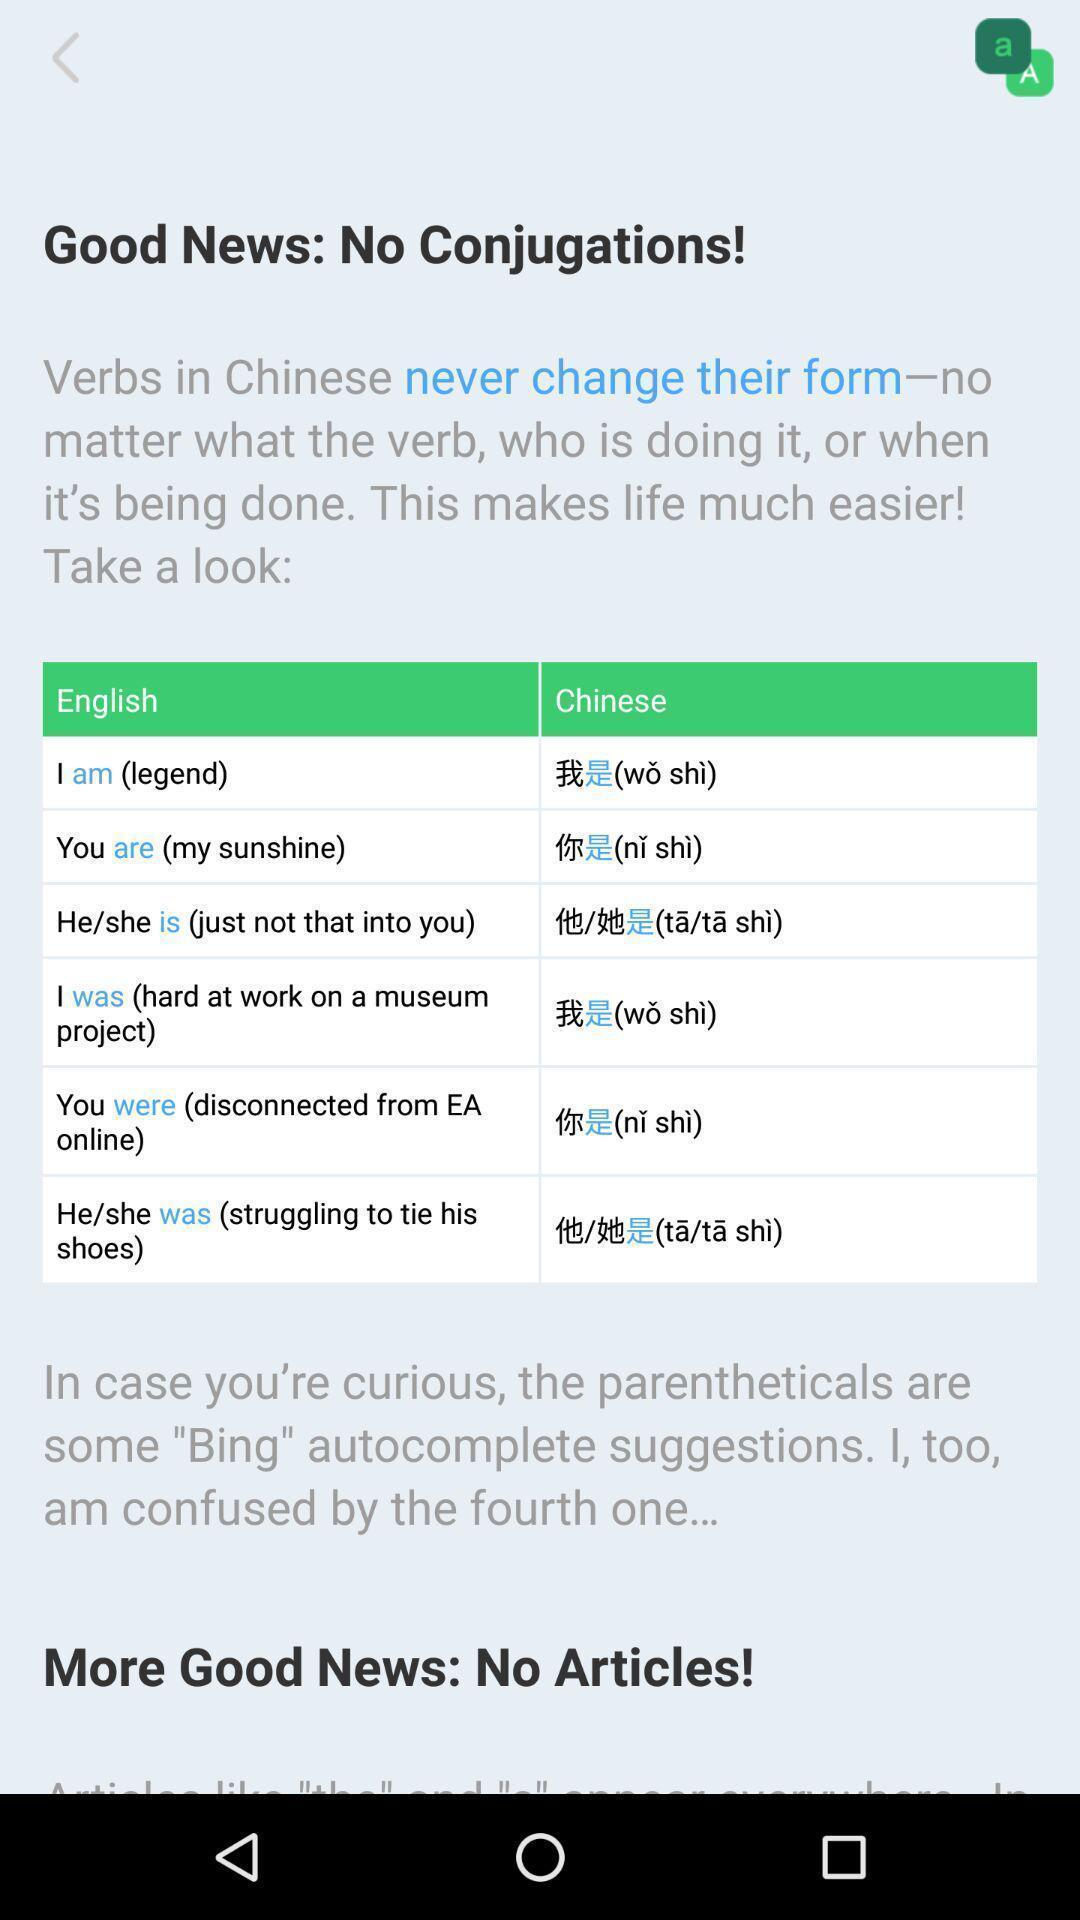Summarize the main components in this picture. Screen page displaying information in language translation app. 